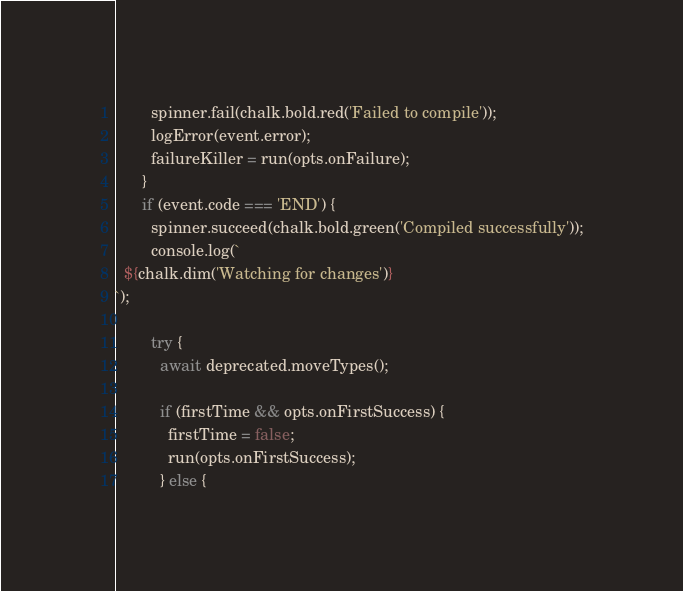<code> <loc_0><loc_0><loc_500><loc_500><_TypeScript_>        spinner.fail(chalk.bold.red('Failed to compile'));
        logError(event.error);
        failureKiller = run(opts.onFailure);
      }
      if (event.code === 'END') {
        spinner.succeed(chalk.bold.green('Compiled successfully'));
        console.log(`
  ${chalk.dim('Watching for changes')}
`);

        try {
          await deprecated.moveTypes();

          if (firstTime && opts.onFirstSuccess) {
            firstTime = false;
            run(opts.onFirstSuccess);
          } else {</code> 